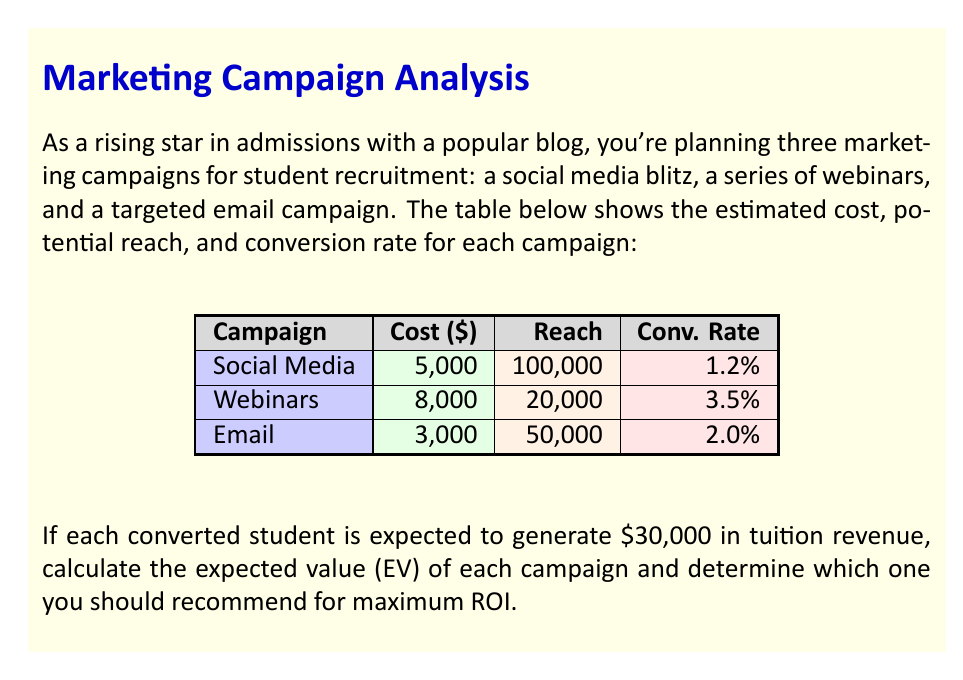What is the answer to this math problem? To solve this problem, we'll follow these steps:

1) Calculate the number of converted students for each campaign:
   Converted students = Reach × Conversion Rate

2) Calculate the revenue generated by each campaign:
   Revenue = Converted students × Revenue per student

3) Calculate the expected value (EV) for each campaign:
   EV = Revenue - Cost

4) Compare the EVs to determine the best campaign.

Let's calculate for each campaign:

Social Media Campaign:
1) Converted students = 100,000 × 1.2% = 1,200
2) Revenue = 1,200 × $30,000 = $36,000,000
3) EV = $36,000,000 - $5,000 = $35,995,000

Webinars Campaign:
1) Converted students = 20,000 × 3.5% = 700
2) Revenue = 700 × $30,000 = $21,000,000
3) EV = $21,000,000 - $8,000 = $20,992,000

Email Campaign:
1) Converted students = 50,000 × 2.0% = 1,000
2) Revenue = 1,000 × $30,000 = $30,000,000
3) EV = $30,000,000 - $3,000 = $29,997,000

Comparing the EVs:
Social Media: $35,995,000
Webinars: $20,992,000
Email: $29,997,000

The Social Media campaign has the highest expected value and should be recommended for maximum ROI.
Answer: $35,995,000 (Social Media campaign) 